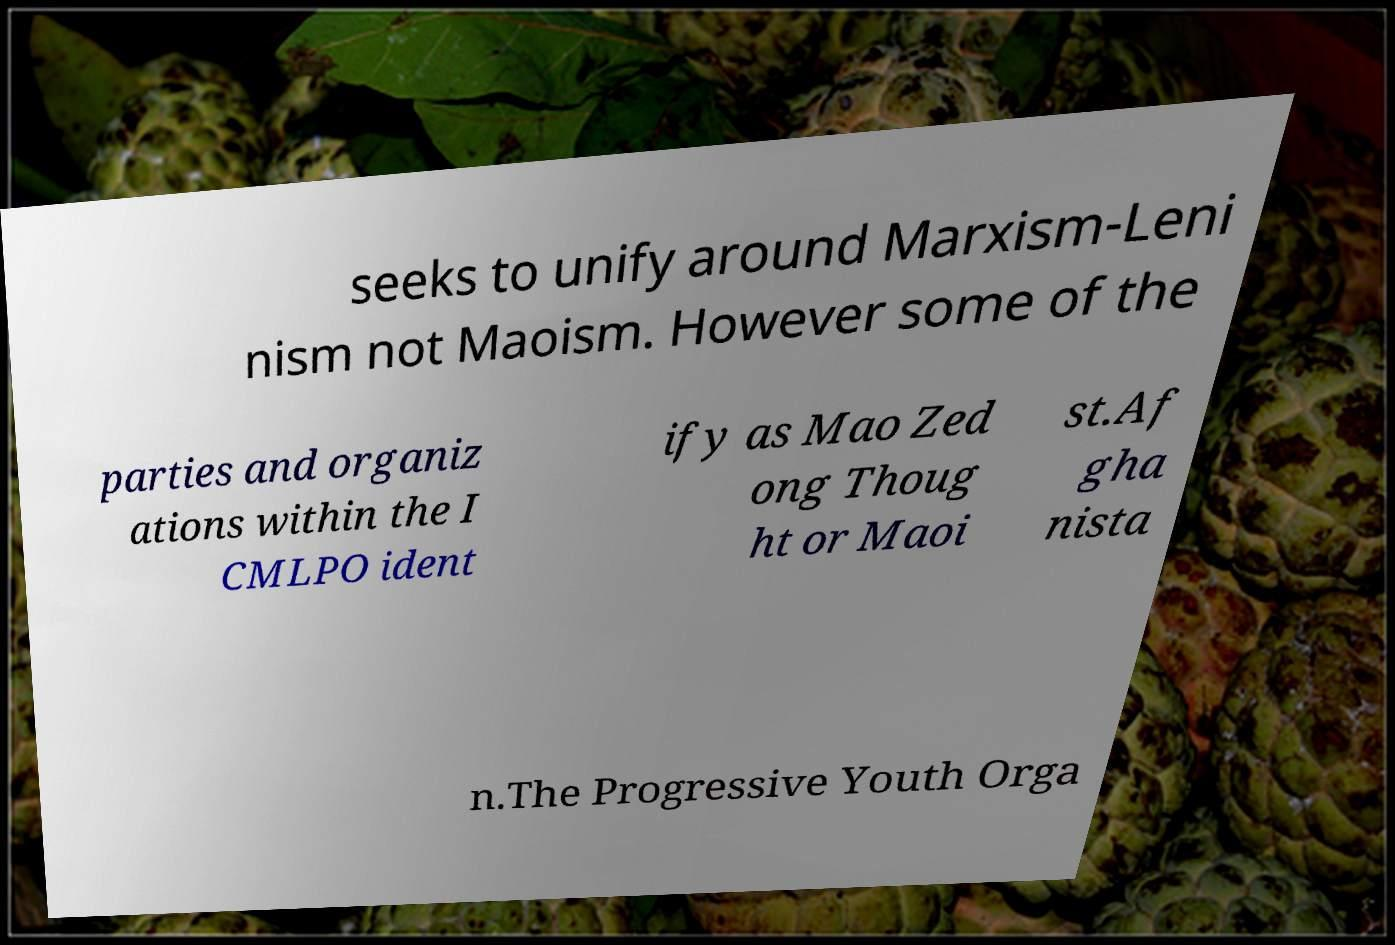Could you assist in decoding the text presented in this image and type it out clearly? seeks to unify around Marxism-Leni nism not Maoism. However some of the parties and organiz ations within the I CMLPO ident ify as Mao Zed ong Thoug ht or Maoi st.Af gha nista n.The Progressive Youth Orga 